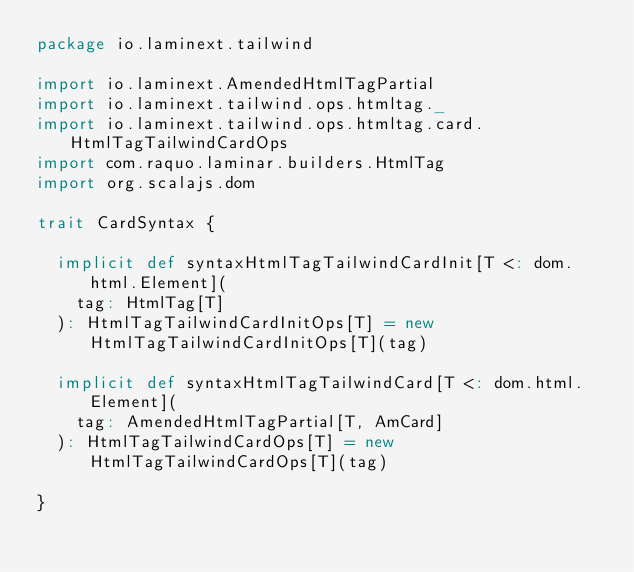<code> <loc_0><loc_0><loc_500><loc_500><_Scala_>package io.laminext.tailwind

import io.laminext.AmendedHtmlTagPartial
import io.laminext.tailwind.ops.htmltag._
import io.laminext.tailwind.ops.htmltag.card.HtmlTagTailwindCardOps
import com.raquo.laminar.builders.HtmlTag
import org.scalajs.dom

trait CardSyntax {

  implicit def syntaxHtmlTagTailwindCardInit[T <: dom.html.Element](
    tag: HtmlTag[T]
  ): HtmlTagTailwindCardInitOps[T] = new HtmlTagTailwindCardInitOps[T](tag)

  implicit def syntaxHtmlTagTailwindCard[T <: dom.html.Element](
    tag: AmendedHtmlTagPartial[T, AmCard]
  ): HtmlTagTailwindCardOps[T] = new HtmlTagTailwindCardOps[T](tag)

}
</code> 